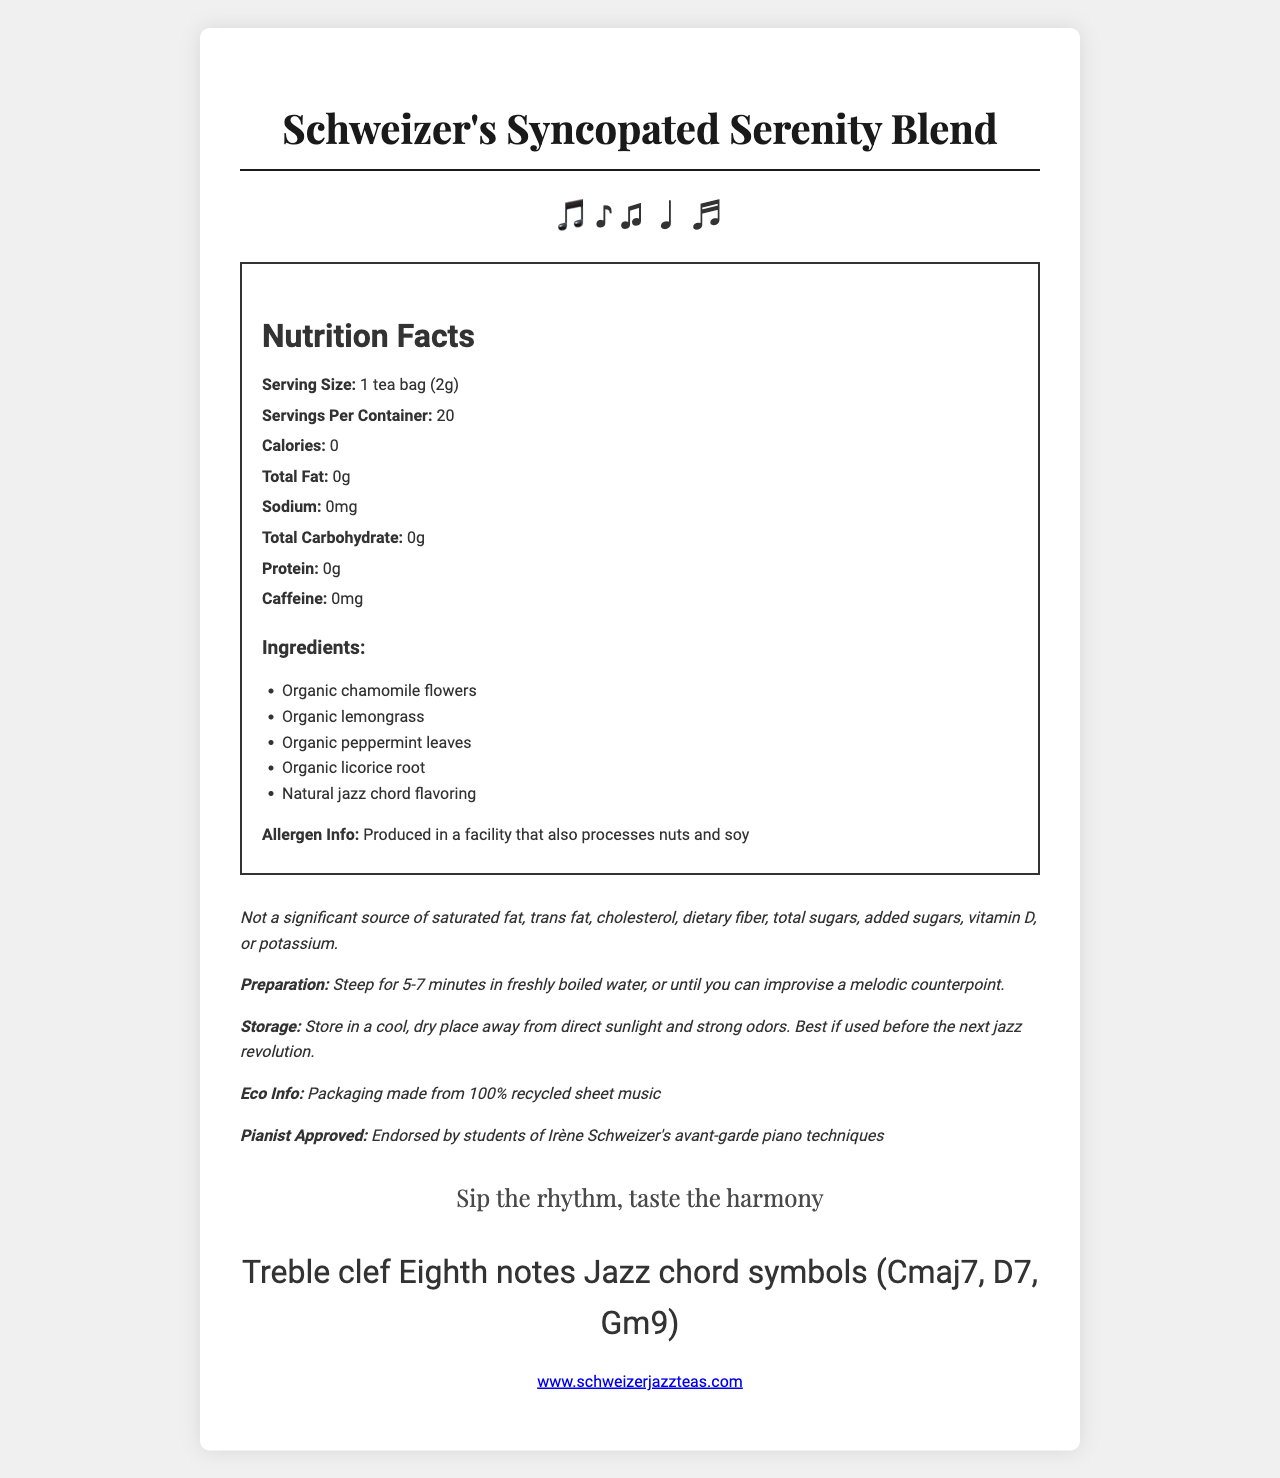what is the serving size of Schweizer's Syncopated Serenity Blend? The serving size is listed in the Nutrition Facts section of the document.
Answer: 1 tea bag (2g) how many servings are there per container? The number of servings per container is specified as 20 in the Nutrition Facts section.
Answer: 20 how many calories are in one serving of this tea? The calorie count per serving is mentioned as 0 in the Nutrition Facts section.
Answer: 0 what kind of flavoring is used in this tea? The list of ingredients includes "Natural jazz chord flavoring."
Answer: Natural jazz chord flavoring what is the recommended steeping time for this tea? The preparation instructions recommend steeping for 5-7 minutes.
Answer: 5-7 minutes how much caffeine does this tea contain per serving? The Nutrition Facts section states the caffeine content is 0mg per serving.
Answer: 0mg which of the following is NOT an ingredient in this tea? A. Organic chamomile flowers B. Organic peppermint leaves C. Organic green tea The ingredients do not list organic green tea, so this is the correct answer.
Answer: C. Organic green tea what is the recommended storage condition for this tea? A. In the refrigerator B. In a cool, dry place C. In a warm, humid place The storage instructions specify storing in a cool, dry place away from direct sunlight and strong odors.
Answer: B. In a cool, dry place is there any significant amount of vitamin C in this tea? The vitamins and minerals section indicates that the tea contains 0% vitamin C.
Answer: No does the packaging of this tea use eco-friendly materials? The eco info states that the packaging is made from 100% recycled sheet music.
Answer: Yes is this tea produced in a facility that processes gluten? The document mentions the facility processes nuts and soy but does not provide information about gluten.
Answer: Cannot be determined summarize the main idea of the document. This summary captures the main points provided in the document, including nutritional information, unique product features, and special recommendations.
Answer: The document provides detailed information about "Schweizer's Syncopated Serenity Blend" herbal tea, including its nutrition facts, ingredients, allergen information, preparation, and storage instructions. The tea is caffeine-free, containing no calories, fats, sodium, carbohydrates, protein, or vitamins. The packaging is eco-friendly, and the product is endorsed by students of avant-garde piano techniques. 